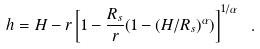Convert formula to latex. <formula><loc_0><loc_0><loc_500><loc_500>h = H - r \left [ 1 - \frac { R _ { s } } { r } ( 1 - ( H / R _ { s } ) ^ { \alpha } ) \right ] ^ { 1 / \alpha } \ .</formula> 